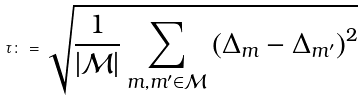Convert formula to latex. <formula><loc_0><loc_0><loc_500><loc_500>\tau \colon = \sqrt { \frac { 1 } { | \mathcal { M } | } \sum _ { m , m ^ { \prime } \in \mathcal { M } } \left ( \Delta _ { m } - \Delta _ { m ^ { \prime } } \right ) ^ { 2 } }</formula> 